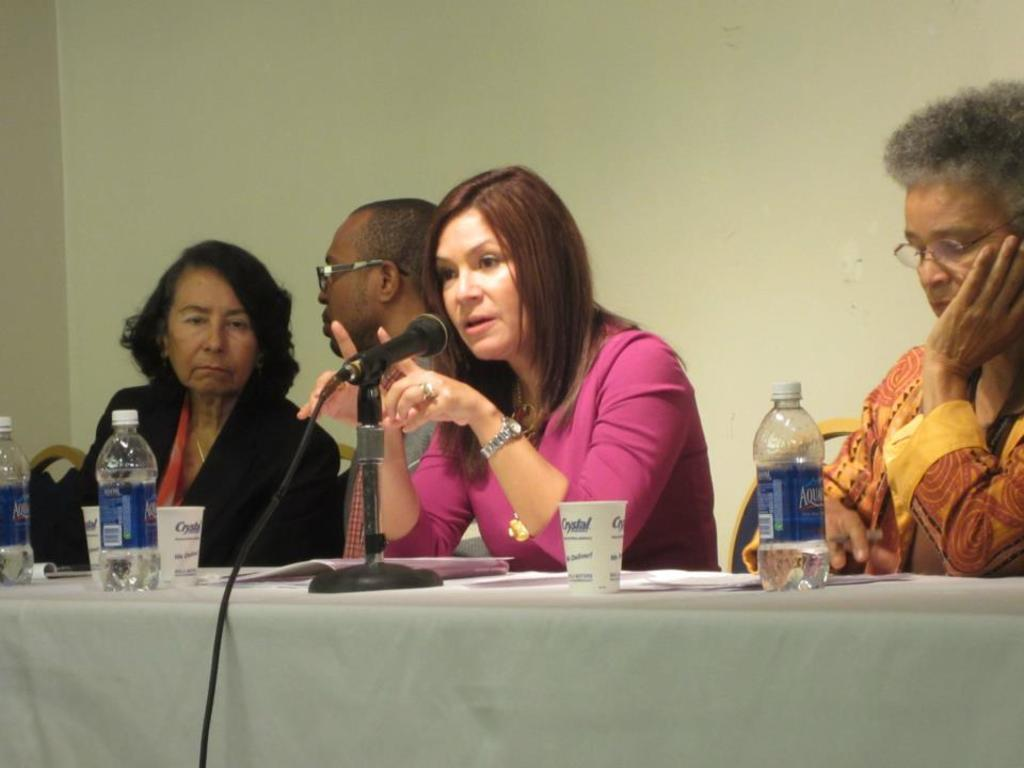What is the arrangement of the people in the image? There is a group of people in the image, and they are seated on chairs. What objects are present on the table in the image? There is a bottle, a cup, and a microphone on the table in the image. What type of machine is being used by the people on stage in the image? There is no stage or machine present in the image; it only shows a group of people seated on chairs with objects on the table. 